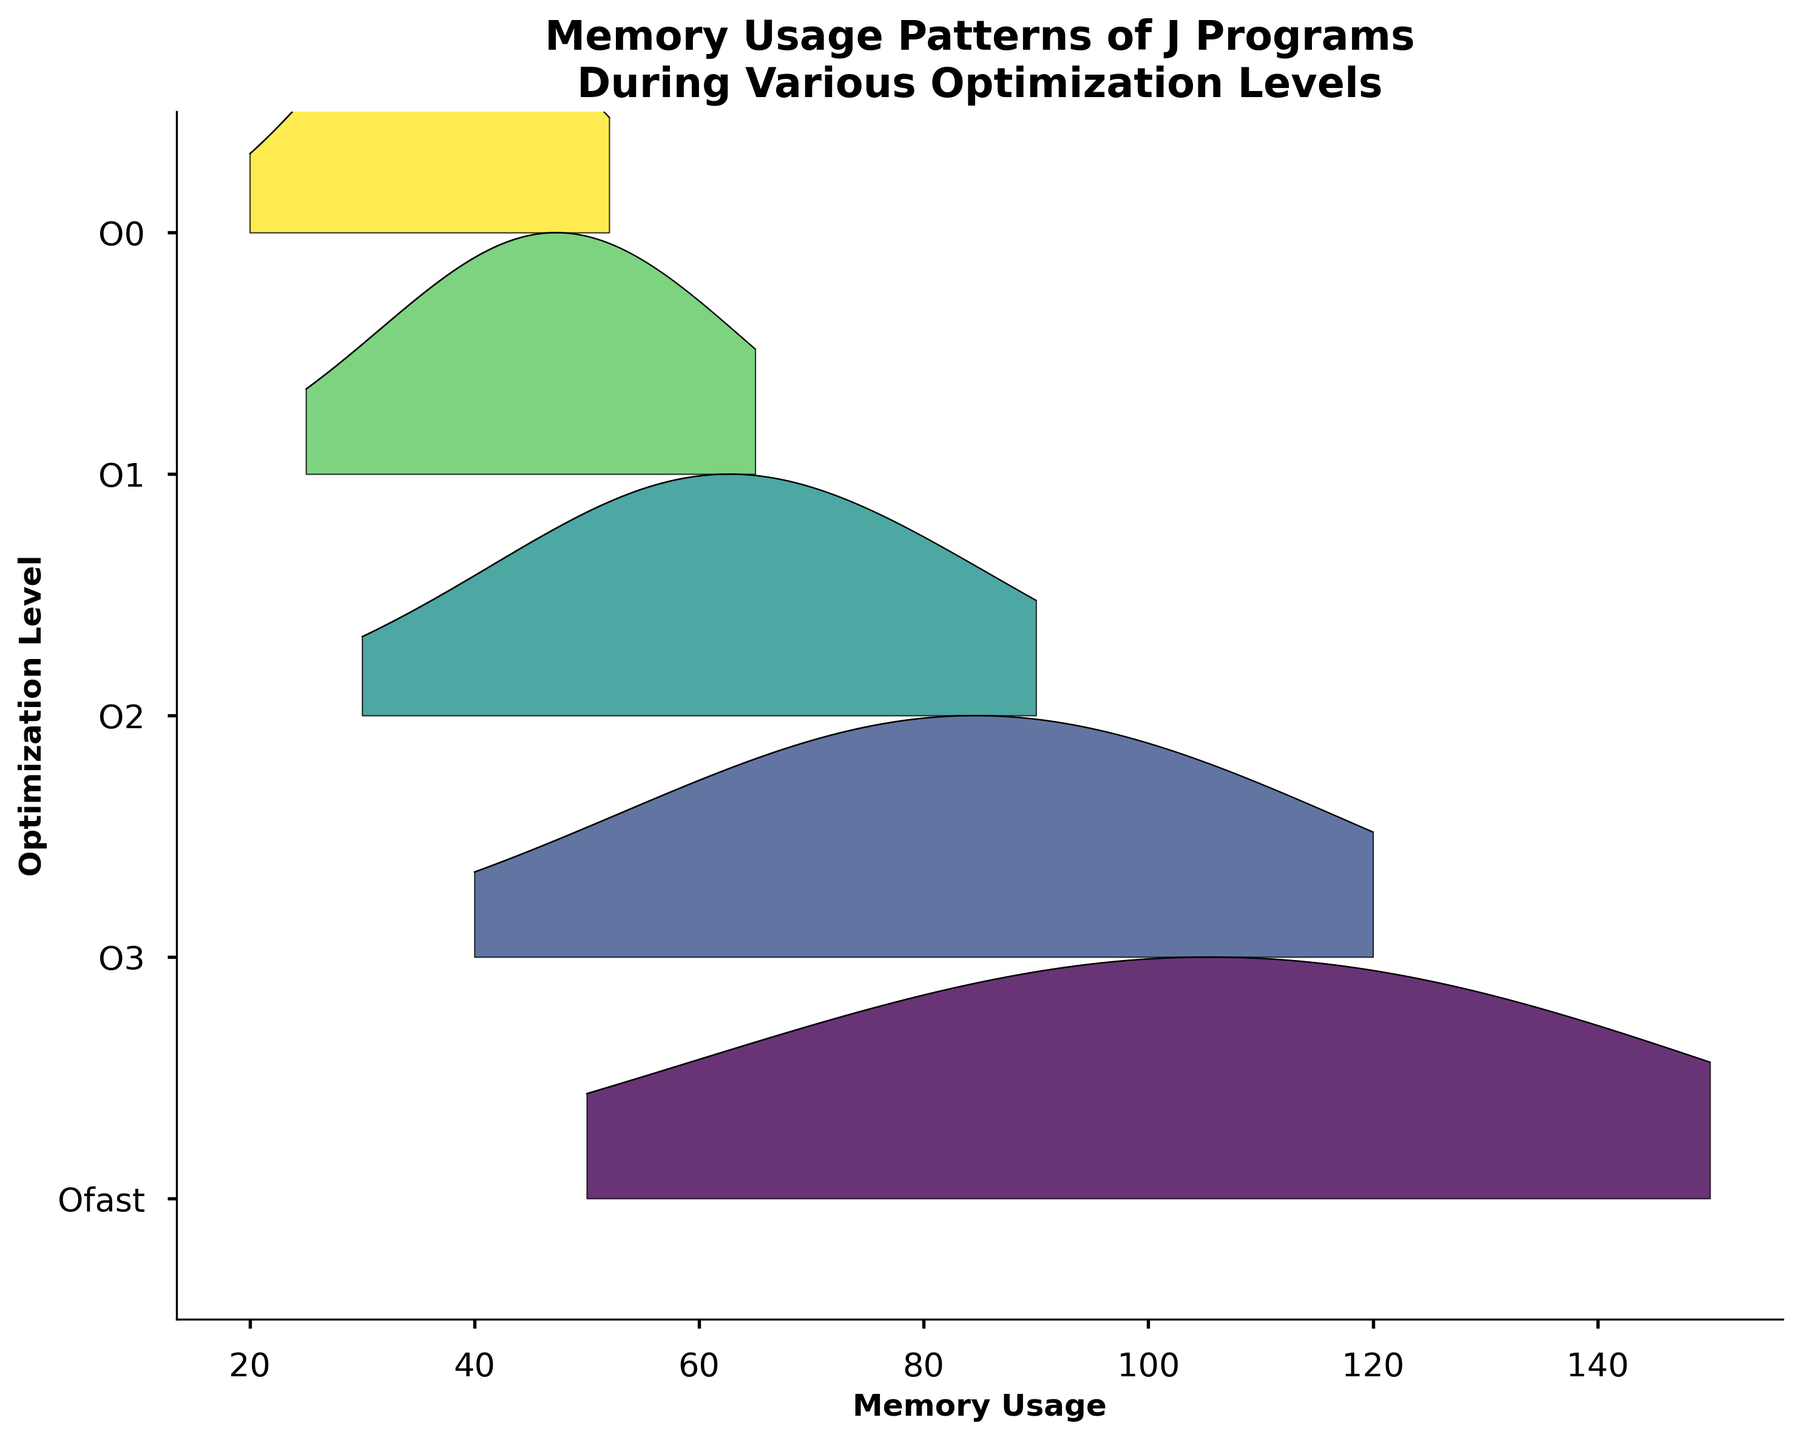What is the title of the plot? The title is generally located at the top of the plot and often describes what is being visualized. Here, the title is "Memory Usage Patterns of J Programs During Various Optimization Levels."
Answer: Memory Usage Patterns of J Programs During Various Optimization Levels How many optimization levels are displayed on the y-axis? The plot shows different optimization levels on the y-axis. By counting the labels, we see six optimization levels: O0, O1, O2, O3, and Ofast.
Answer: 6 Which optimization level has the highest density peak? To determine the highest density peak, we look at which ridgeline has the tallest peak. Based on the plot, "O0" appears to have the highest density around a memory usage of 100.
Answer: O0 At what memory usage does the "Ofast" optimization level have its density peak? For the "Ofast" optimization level, the density peak is observed at its highest point around the memory usage value. The peak appears to be around 36.
Answer: 36 Which optimization level shows the maximum spread in memory usage values? The spread can be determined by looking at the range of memory usage values each ridgeline covers. "O0" seems to have the widest range, approximately from 50 to 150.
Answer: O0 What is the memory usage range for the "O3" optimization level? To find the range, observe the memory usage values where the density extends for "O3." The range is approximately from 25 to 65.
Answer: 25 to 65 How does the density of memory usage at level "O2" compare to that at level "O1"? Compare the height of the ridgeline peaks for "O2" and "O1". "O2" has a slightly higher peak density around 60 compared to the peak density values in "O1".
Answer: "O2" has a higher peak density Which optimization level shows the minimum memory usage value? Inspecting all the ridgelines, "Ofast" shows the minimum memory usage at around 20, which is lower than any other level displayed.
Answer: Ofast What is the average memory usage range across all optimization levels? Calculate the average of the memory usage ranges for all levels. The ranges were: O0 (50 to 150), O1 (40 to 120), O2 (30 to 90), O3 (25 to 65), and Ofast (20 to 52). This gives average of ((100 + 80 + 60 + 40 + 32)/5).
Answer: 62.4 